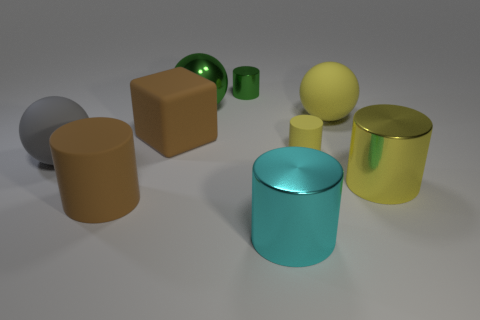Is the number of cyan cylinders that are behind the green ball the same as the number of brown rubber cylinders that are to the left of the cube?
Ensure brevity in your answer.  No. What number of cubes are either small green metal objects or yellow matte objects?
Provide a succinct answer. 0. What number of other objects are there of the same material as the large cube?
Offer a terse response. 4. The big brown rubber object that is behind the tiny yellow cylinder has what shape?
Offer a terse response. Cube. There is a yellow thing behind the tiny matte cylinder that is in front of the big yellow sphere; what is its material?
Offer a terse response. Rubber. Are there more large green things that are on the left side of the small rubber cylinder than cyan things?
Give a very brief answer. No. What number of other things are the same color as the tiny metal cylinder?
Keep it short and to the point. 1. The matte object that is the same size as the green cylinder is what shape?
Ensure brevity in your answer.  Cylinder. There is a big metal cylinder behind the large shiny cylinder that is in front of the yellow shiny object; what number of brown cylinders are in front of it?
Give a very brief answer. 1. What number of shiny objects are small blue cylinders or big spheres?
Ensure brevity in your answer.  1. 